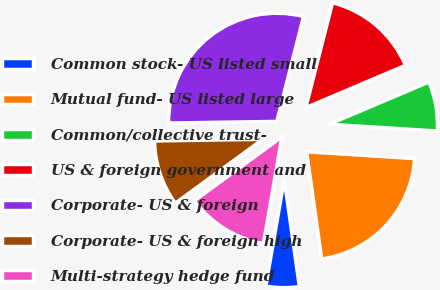Convert chart to OTSL. <chart><loc_0><loc_0><loc_500><loc_500><pie_chart><fcel>Common stock- US listed small<fcel>Mutual fund- US listed large<fcel>Common/collective trust-<fcel>US & foreign government and<fcel>Corporate- US & foreign<fcel>Corporate- US & foreign high<fcel>Multi-strategy hedge fund<nl><fcel>4.95%<fcel>21.78%<fcel>7.38%<fcel>14.65%<fcel>29.21%<fcel>9.8%<fcel>12.23%<nl></chart> 